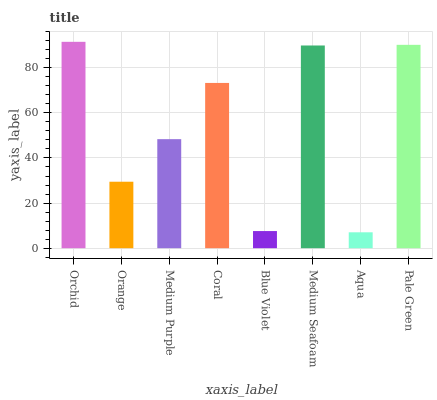Is Aqua the minimum?
Answer yes or no. Yes. Is Orchid the maximum?
Answer yes or no. Yes. Is Orange the minimum?
Answer yes or no. No. Is Orange the maximum?
Answer yes or no. No. Is Orchid greater than Orange?
Answer yes or no. Yes. Is Orange less than Orchid?
Answer yes or no. Yes. Is Orange greater than Orchid?
Answer yes or no. No. Is Orchid less than Orange?
Answer yes or no. No. Is Coral the high median?
Answer yes or no. Yes. Is Medium Purple the low median?
Answer yes or no. Yes. Is Medium Seafoam the high median?
Answer yes or no. No. Is Orchid the low median?
Answer yes or no. No. 